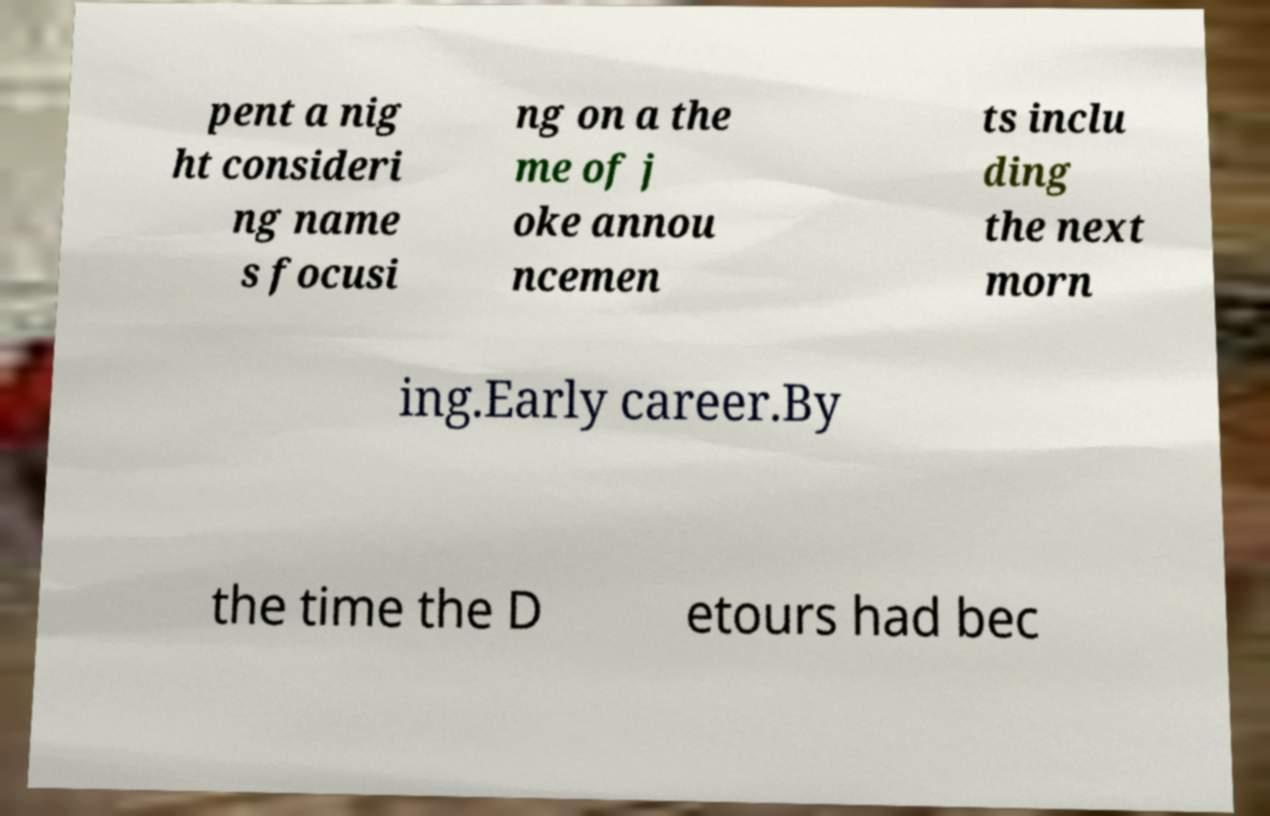Could you extract and type out the text from this image? pent a nig ht consideri ng name s focusi ng on a the me of j oke annou ncemen ts inclu ding the next morn ing.Early career.By the time the D etours had bec 